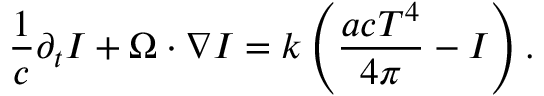Convert formula to latex. <formula><loc_0><loc_0><loc_500><loc_500>\frac { 1 } { c } \partial _ { t } I + \Omega \cdot \nabla I = k \left ( \frac { a c T ^ { 4 } } { 4 \pi } - I \right ) .</formula> 